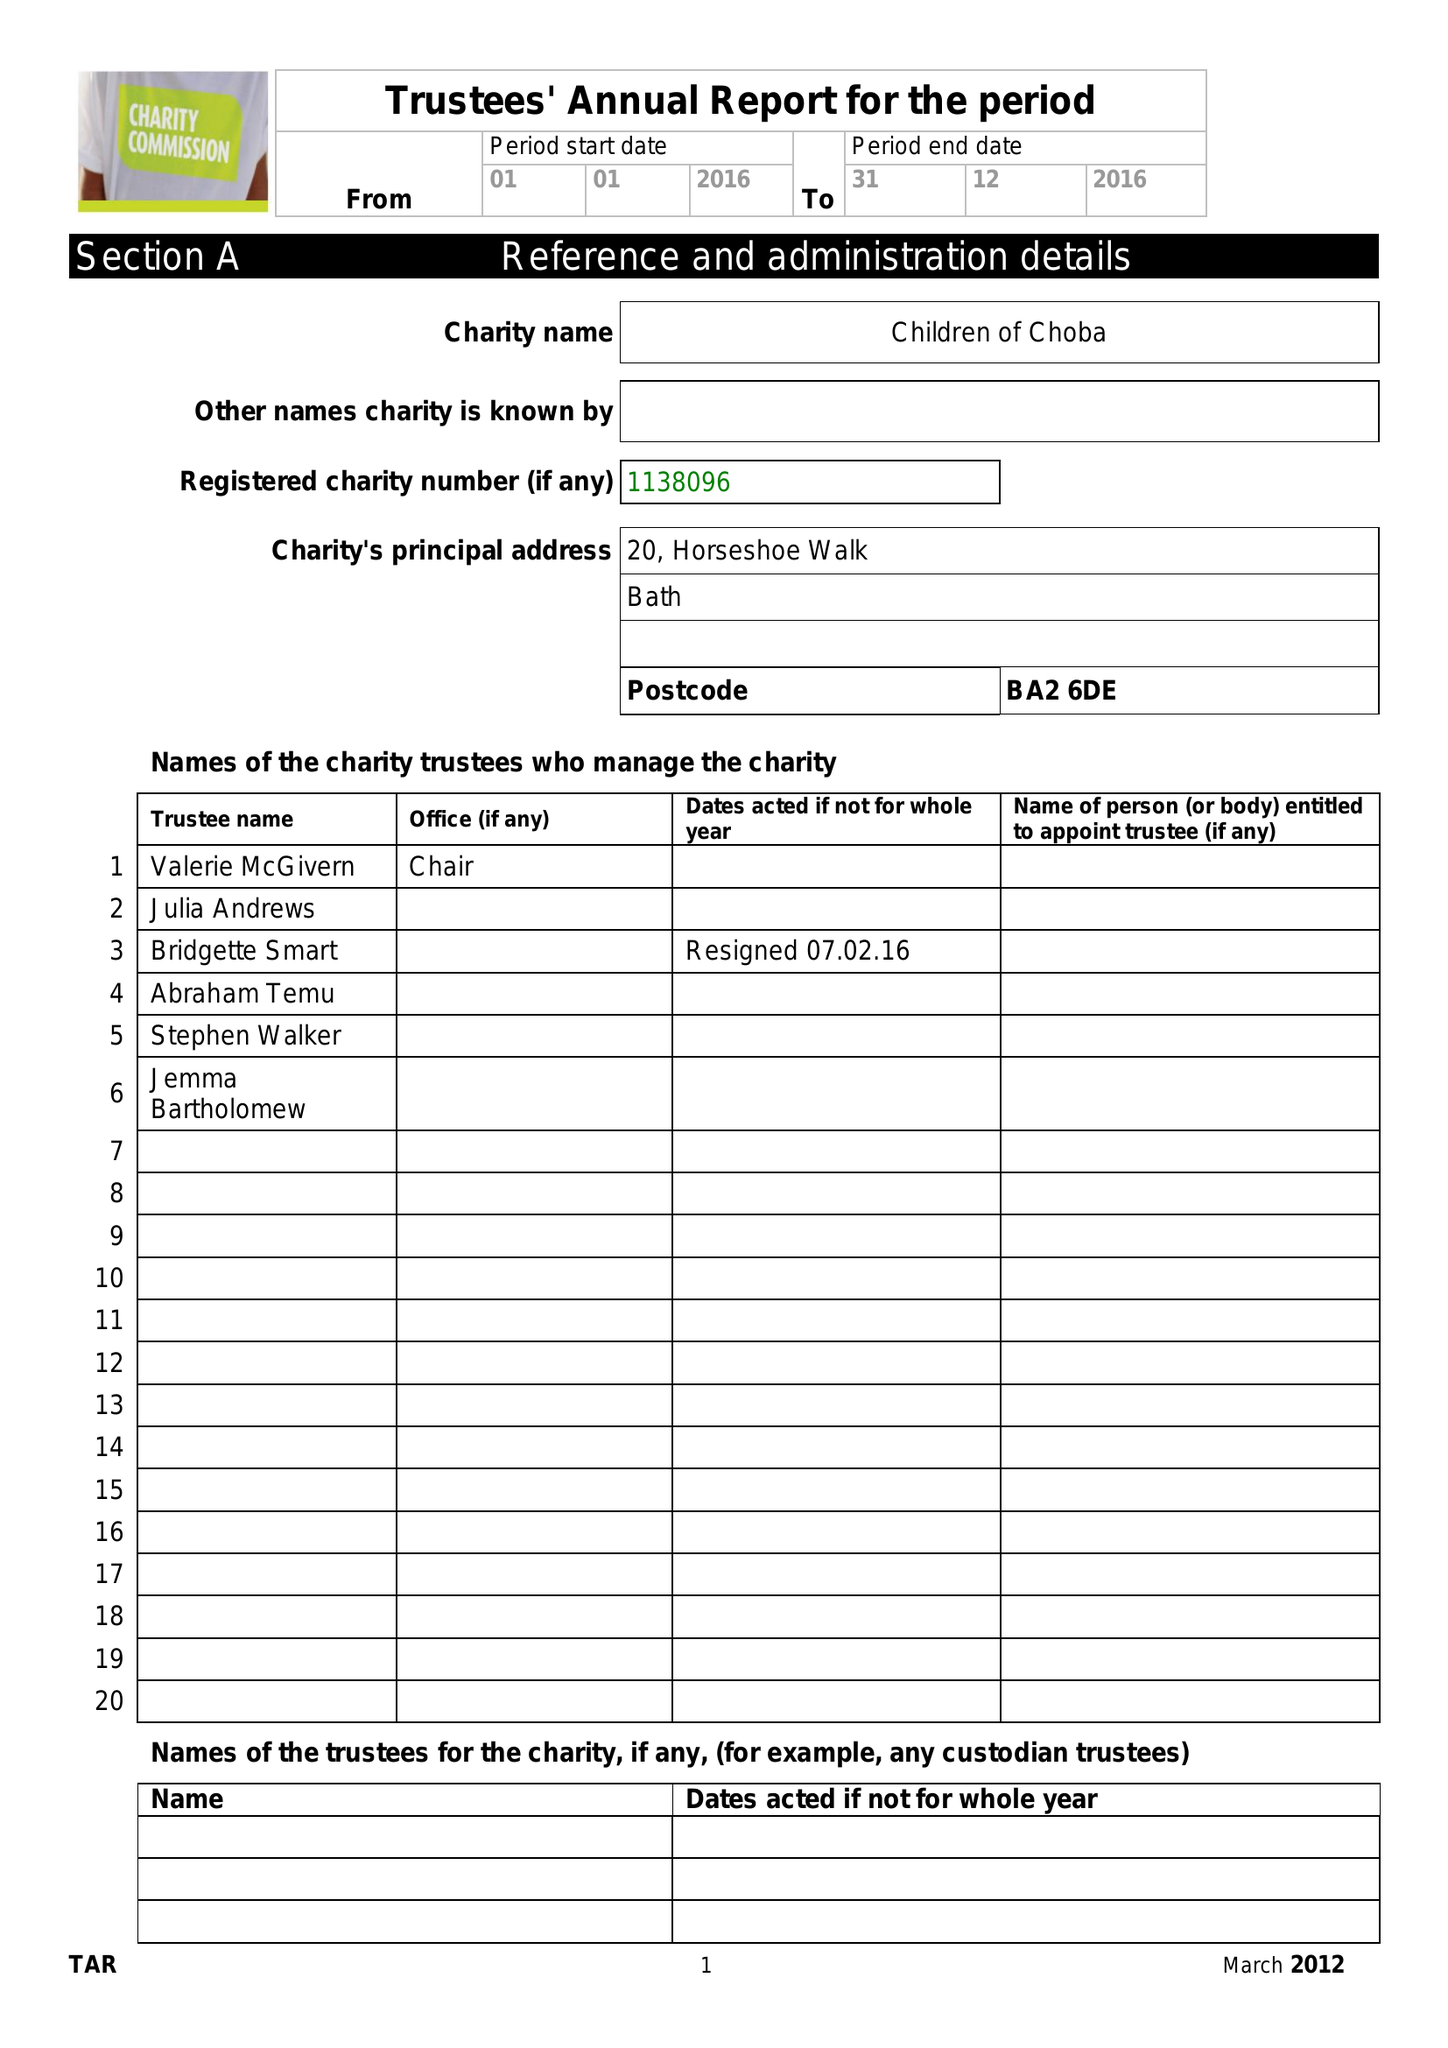What is the value for the address__postcode?
Answer the question using a single word or phrase. BA2 6DE 